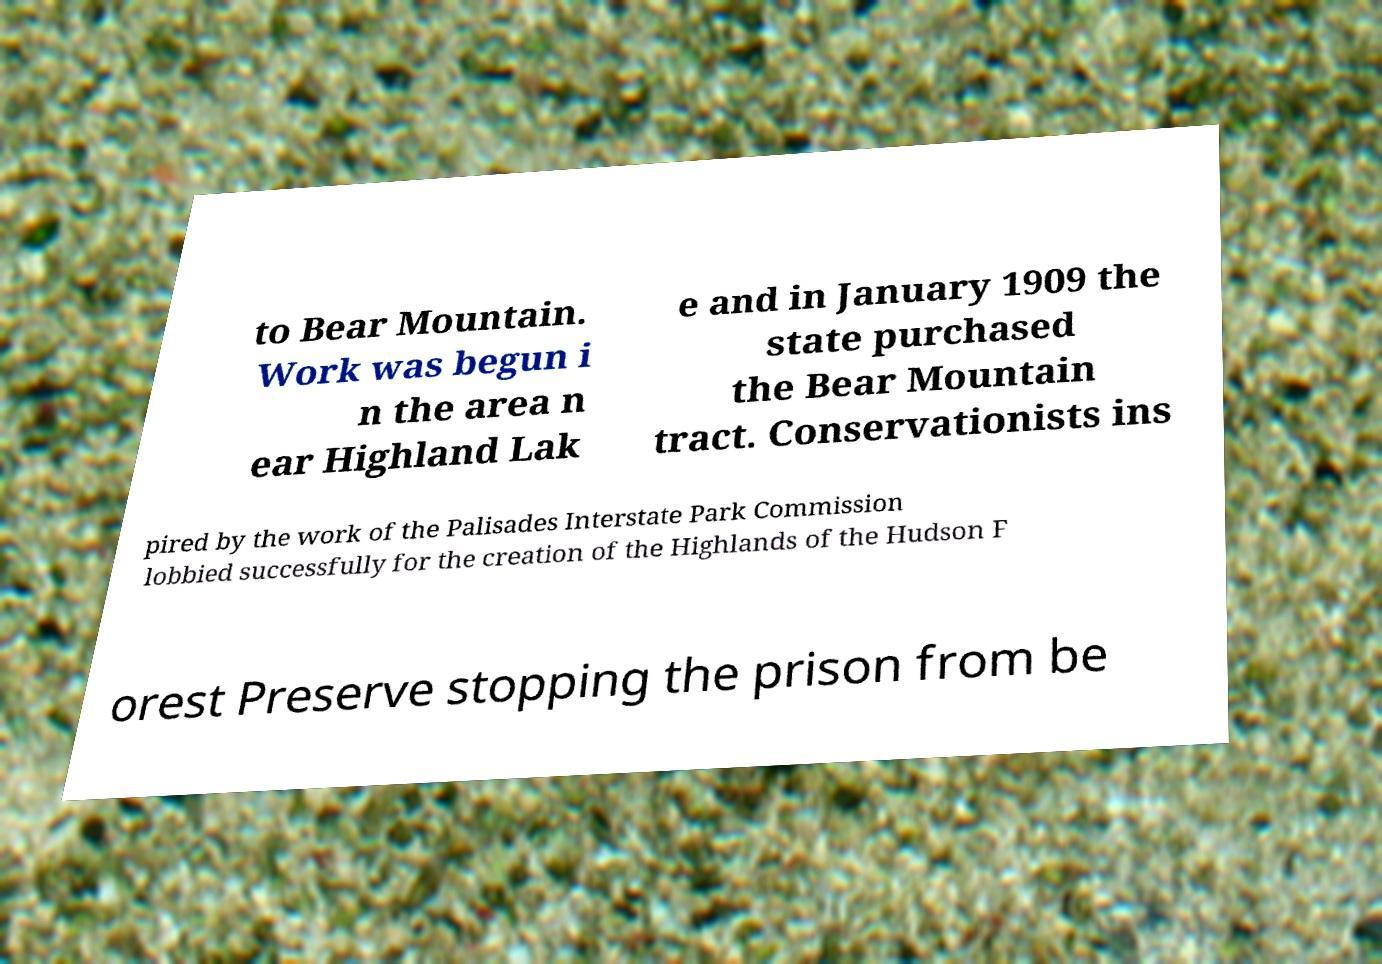Could you extract and type out the text from this image? to Bear Mountain. Work was begun i n the area n ear Highland Lak e and in January 1909 the state purchased the Bear Mountain tract. Conservationists ins pired by the work of the Palisades Interstate Park Commission lobbied successfully for the creation of the Highlands of the Hudson F orest Preserve stopping the prison from be 